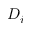<formula> <loc_0><loc_0><loc_500><loc_500>D _ { i }</formula> 